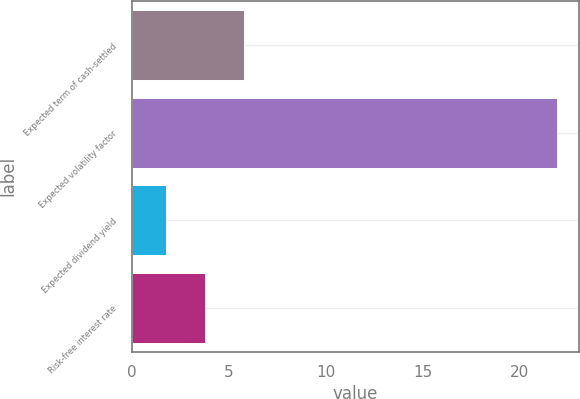Convert chart. <chart><loc_0><loc_0><loc_500><loc_500><bar_chart><fcel>Expected term of cash-settled<fcel>Expected volatility factor<fcel>Expected dividend yield<fcel>Risk-free interest rate<nl><fcel>5.79<fcel>21.96<fcel>1.75<fcel>3.77<nl></chart> 